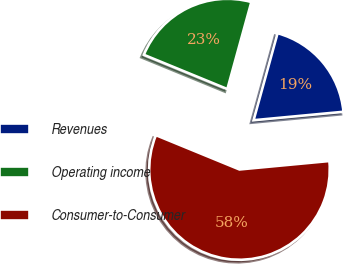<chart> <loc_0><loc_0><loc_500><loc_500><pie_chart><fcel>Revenues<fcel>Operating income<fcel>Consumer-to-Consumer<nl><fcel>19.23%<fcel>23.08%<fcel>57.69%<nl></chart> 